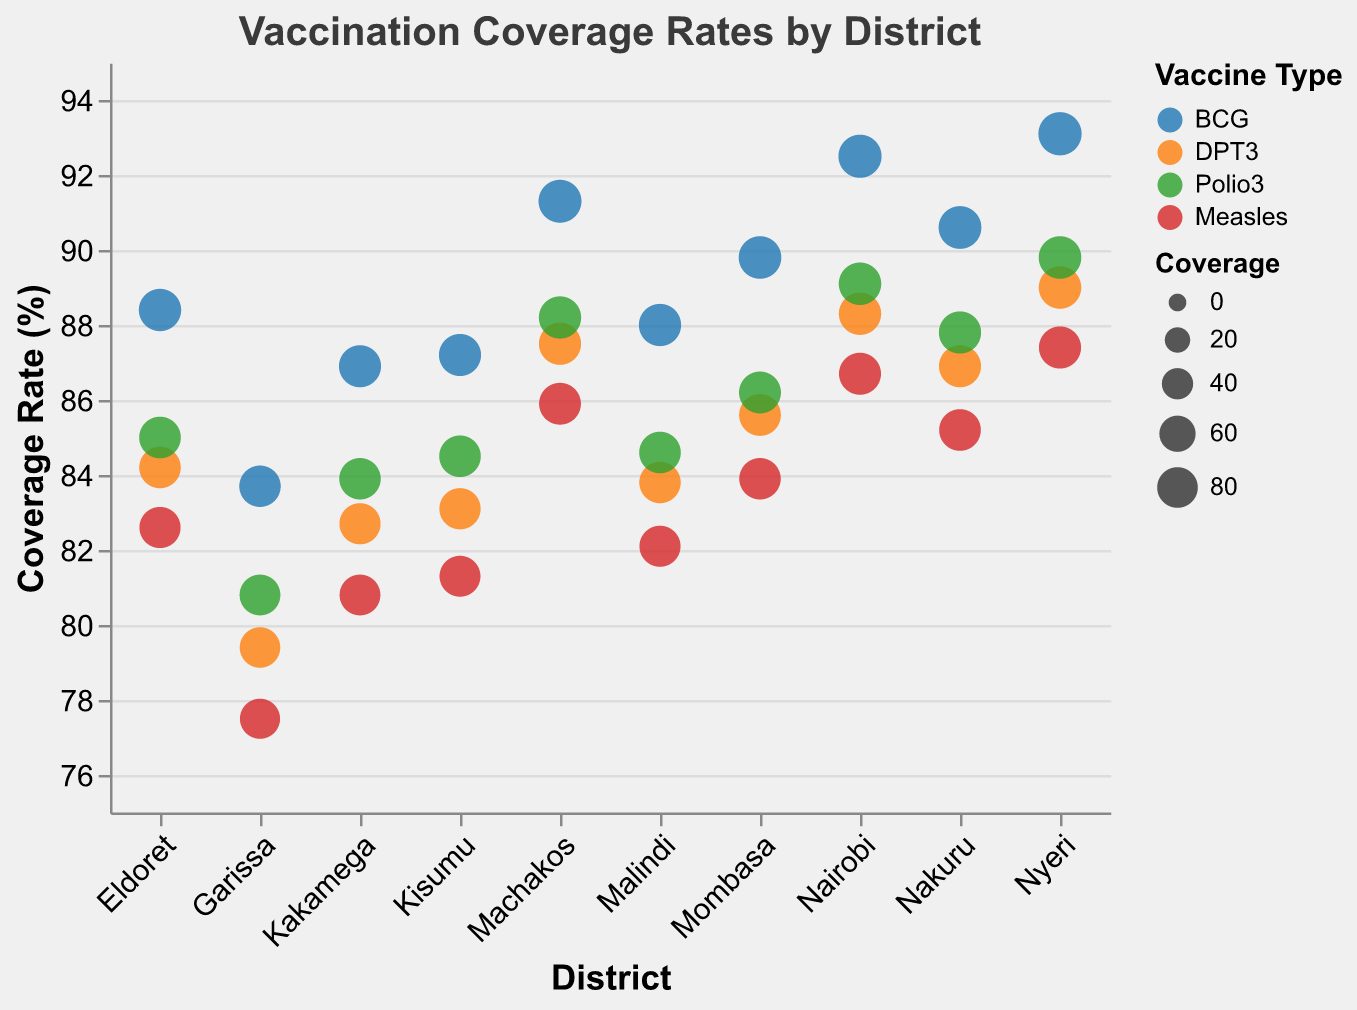What is the title of the plot? The title of the plot is present at the top of the figure. It reads "Vaccination Coverage Rates by District".
Answer: Vaccination Coverage Rates by District Which district has the highest BCG vaccination coverage rate? By looking at the color-coded dots representing each district, Nyeri has the highest BCG coverage rate at 93.1%.
Answer: Nyeri Which vaccine has the lowest overall coverage rates in Garissa? Each vaccine is marked with a different color. The tooltip reveals detailed coverage rates when hovered over each data point. For Garissa, the Measles vaccine has the lowest coverage at 77.5%.
Answer: Measles Compare the DPT3 vaccination rates between Nairobi and Kisumu. Which district has a higher rate and by how much? Nairobi has a DPT3 coverage rate of 88.3%, while Kisumu has 83.1%. The difference is 88.3 - 83.1 = 5.2%. Therefore, Nairobi has a higher rate by 5.2%.
Answer: Nairobi by 5.2% Calculate the average Measles vaccination coverage rate across all districts. Sum the Measles rates for each district (86.7 + 83.9 + 81.3 + 85.2 + 82.6 + 85.9 + 77.5 + 80.8 + 87.4 + 82.1) and then divide by the number of districts (10). The sum is 833.4, so the average is 833.4 / 10 = 83.34%.
Answer: 83.34% Which vaccine type is represented by the green dots? The legend indicates that the green dots represent the Polio3 vaccine.
Answer: Polio3 In which district is the variance between the highest and lowest vaccine coverage rates the greatest, and what is that variance? Calculate the difference between the highest and lowest rates for each district. The largest difference is in Garissa with 83.7% (BCG) - 77.5% (Measles) = 6.2%.
Answer: Garissa, 6.2% How many districts have a Polio3 coverage rate greater than 85%? By examining the color-coded dots and their positions, the districts with Polio3 coverage above 85% are Nairobi (89.1%), Nakuru (87.8%), Nyeri (89.8%), Machakos (88.2%). That makes 4 districts.
Answer: 4 Which district has the closest BCG and DPT3 coverage rates? Check the values of BCG and DPT3 for each district. The closest is Nyeri, with rates of 93.1% and 89.0%, respectively, a difference of 4.1%.
Answer: Nyeri Which vaccines show a coverage rate above 90% in at least one district? By scanning through the coverage rates and districts, the BCG and Polio3 vaccines show rates above 90% in Nyeri (93.1% BCG, 89.8% Polio3), and Nairobi (92.5% BCG).
Answer: BCG, Polio3 